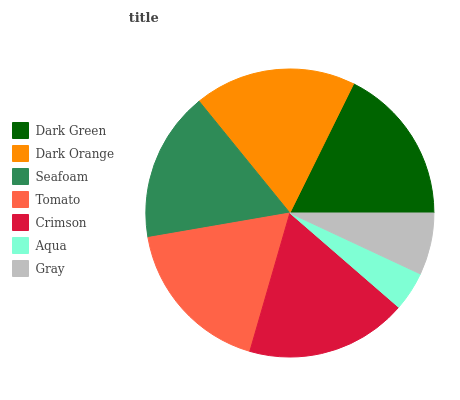Is Aqua the minimum?
Answer yes or no. Yes. Is Dark Orange the maximum?
Answer yes or no. Yes. Is Seafoam the minimum?
Answer yes or no. No. Is Seafoam the maximum?
Answer yes or no. No. Is Dark Orange greater than Seafoam?
Answer yes or no. Yes. Is Seafoam less than Dark Orange?
Answer yes or no. Yes. Is Seafoam greater than Dark Orange?
Answer yes or no. No. Is Dark Orange less than Seafoam?
Answer yes or no. No. Is Dark Green the high median?
Answer yes or no. Yes. Is Dark Green the low median?
Answer yes or no. Yes. Is Tomato the high median?
Answer yes or no. No. Is Seafoam the low median?
Answer yes or no. No. 